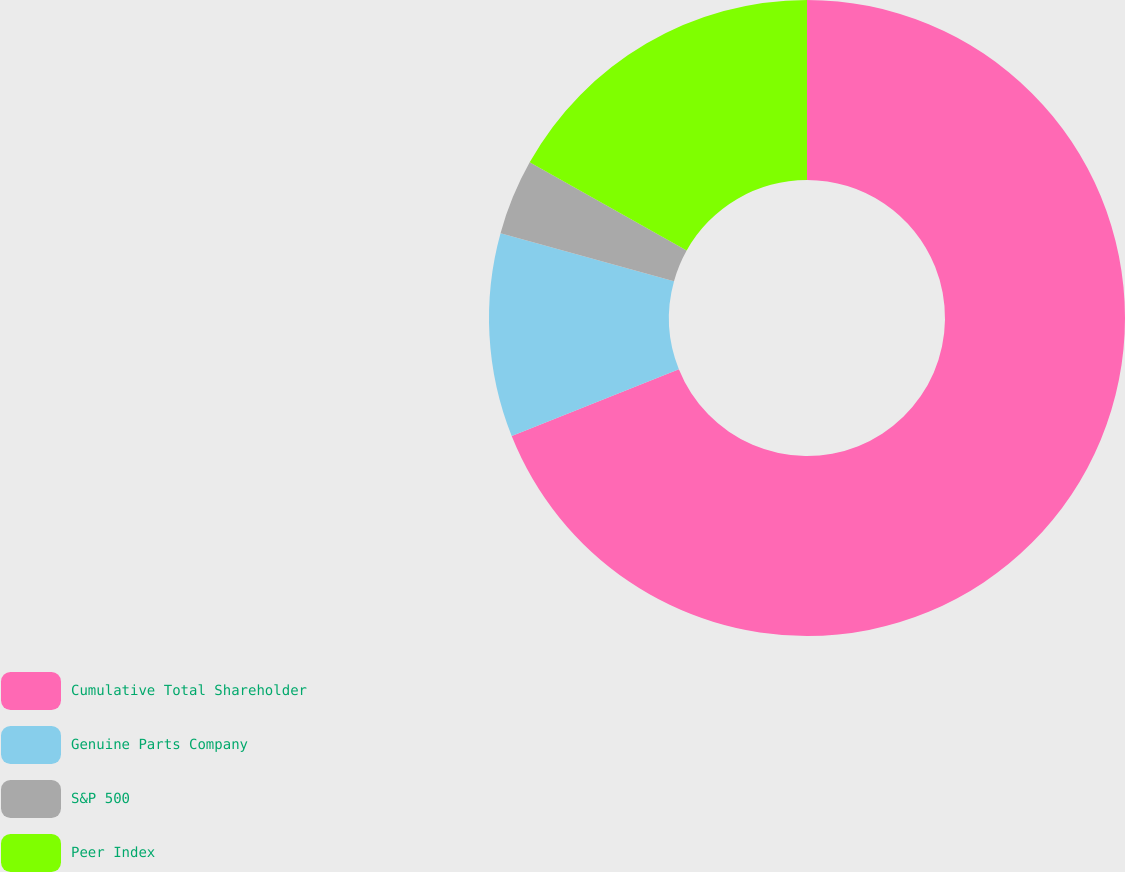Convert chart. <chart><loc_0><loc_0><loc_500><loc_500><pie_chart><fcel>Cumulative Total Shareholder<fcel>Genuine Parts Company<fcel>S&P 500<fcel>Peer Index<nl><fcel>68.95%<fcel>10.35%<fcel>3.84%<fcel>16.86%<nl></chart> 